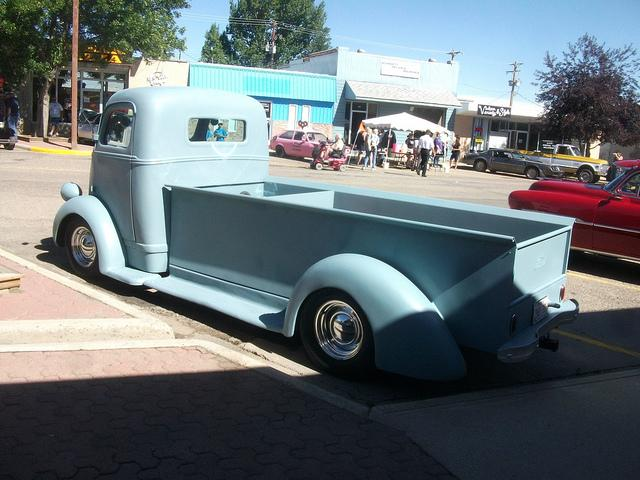What color is the strange old truck? blue 